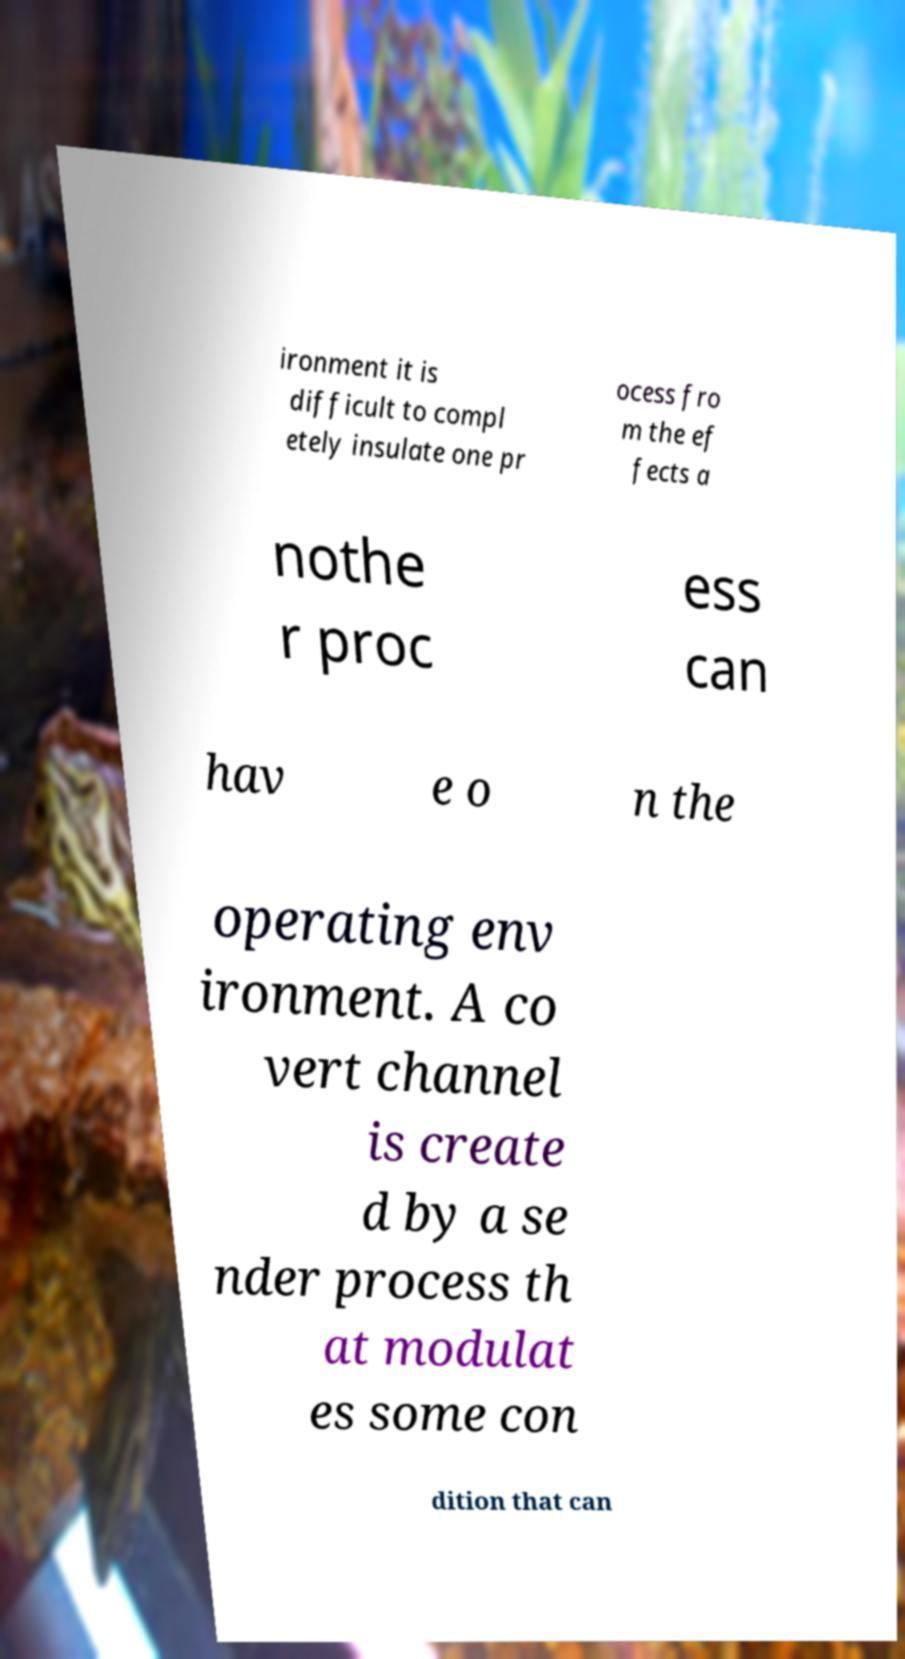There's text embedded in this image that I need extracted. Can you transcribe it verbatim? ironment it is difficult to compl etely insulate one pr ocess fro m the ef fects a nothe r proc ess can hav e o n the operating env ironment. A co vert channel is create d by a se nder process th at modulat es some con dition that can 